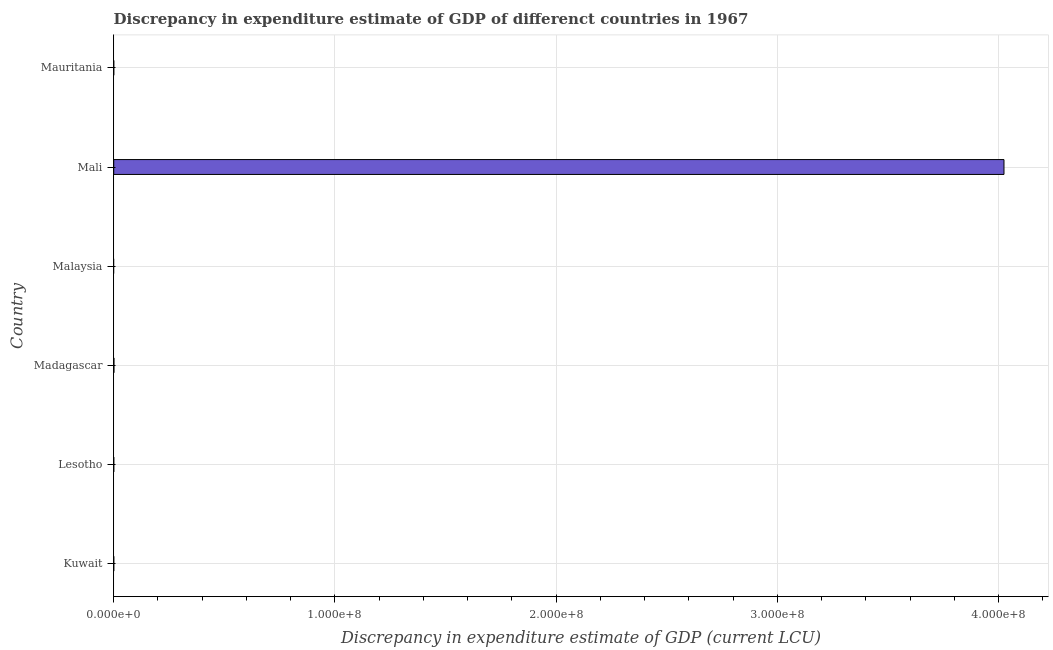Does the graph contain any zero values?
Give a very brief answer. Yes. Does the graph contain grids?
Make the answer very short. Yes. What is the title of the graph?
Keep it short and to the point. Discrepancy in expenditure estimate of GDP of differenct countries in 1967. What is the label or title of the X-axis?
Make the answer very short. Discrepancy in expenditure estimate of GDP (current LCU). Across all countries, what is the maximum discrepancy in expenditure estimate of gdp?
Offer a terse response. 4.02e+08. Across all countries, what is the minimum discrepancy in expenditure estimate of gdp?
Make the answer very short. 0. In which country was the discrepancy in expenditure estimate of gdp maximum?
Provide a succinct answer. Mali. What is the sum of the discrepancy in expenditure estimate of gdp?
Your response must be concise. 4.03e+08. What is the difference between the discrepancy in expenditure estimate of gdp in Madagascar and Mali?
Make the answer very short. -4.02e+08. What is the average discrepancy in expenditure estimate of gdp per country?
Provide a short and direct response. 6.71e+07. What is the median discrepancy in expenditure estimate of gdp?
Give a very brief answer. 0. In how many countries, is the discrepancy in expenditure estimate of gdp greater than 300000000 LCU?
Provide a short and direct response. 1. What is the difference between the highest and the lowest discrepancy in expenditure estimate of gdp?
Ensure brevity in your answer.  4.02e+08. In how many countries, is the discrepancy in expenditure estimate of gdp greater than the average discrepancy in expenditure estimate of gdp taken over all countries?
Your answer should be very brief. 1. How many bars are there?
Ensure brevity in your answer.  2. What is the difference between two consecutive major ticks on the X-axis?
Make the answer very short. 1.00e+08. What is the Discrepancy in expenditure estimate of GDP (current LCU) of Kuwait?
Your response must be concise. 0. What is the Discrepancy in expenditure estimate of GDP (current LCU) of Madagascar?
Offer a very short reply. 7.99e+04. What is the Discrepancy in expenditure estimate of GDP (current LCU) of Mali?
Provide a short and direct response. 4.02e+08. What is the difference between the Discrepancy in expenditure estimate of GDP (current LCU) in Madagascar and Mali?
Your answer should be very brief. -4.02e+08. 